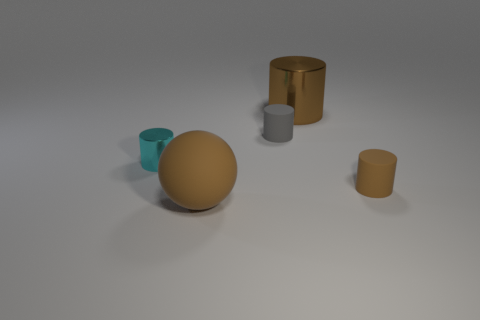Add 5 small matte objects. How many objects exist? 10 Subtract all cylinders. How many objects are left? 1 Subtract 0 cyan blocks. How many objects are left? 5 Subtract all big gray rubber things. Subtract all small rubber things. How many objects are left? 3 Add 5 brown cylinders. How many brown cylinders are left? 7 Add 5 brown objects. How many brown objects exist? 8 